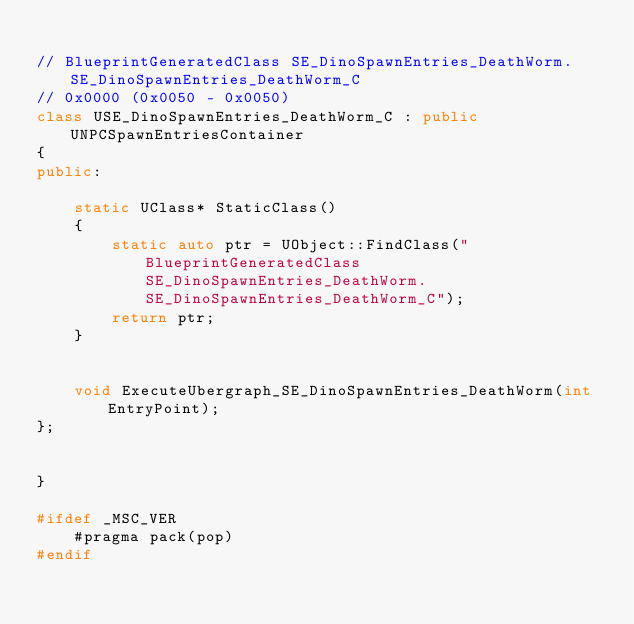Convert code to text. <code><loc_0><loc_0><loc_500><loc_500><_C++_>
// BlueprintGeneratedClass SE_DinoSpawnEntries_DeathWorm.SE_DinoSpawnEntries_DeathWorm_C
// 0x0000 (0x0050 - 0x0050)
class USE_DinoSpawnEntries_DeathWorm_C : public UNPCSpawnEntriesContainer
{
public:

	static UClass* StaticClass()
	{
		static auto ptr = UObject::FindClass("BlueprintGeneratedClass SE_DinoSpawnEntries_DeathWorm.SE_DinoSpawnEntries_DeathWorm_C");
		return ptr;
	}


	void ExecuteUbergraph_SE_DinoSpawnEntries_DeathWorm(int EntryPoint);
};


}

#ifdef _MSC_VER
	#pragma pack(pop)
#endif
</code> 